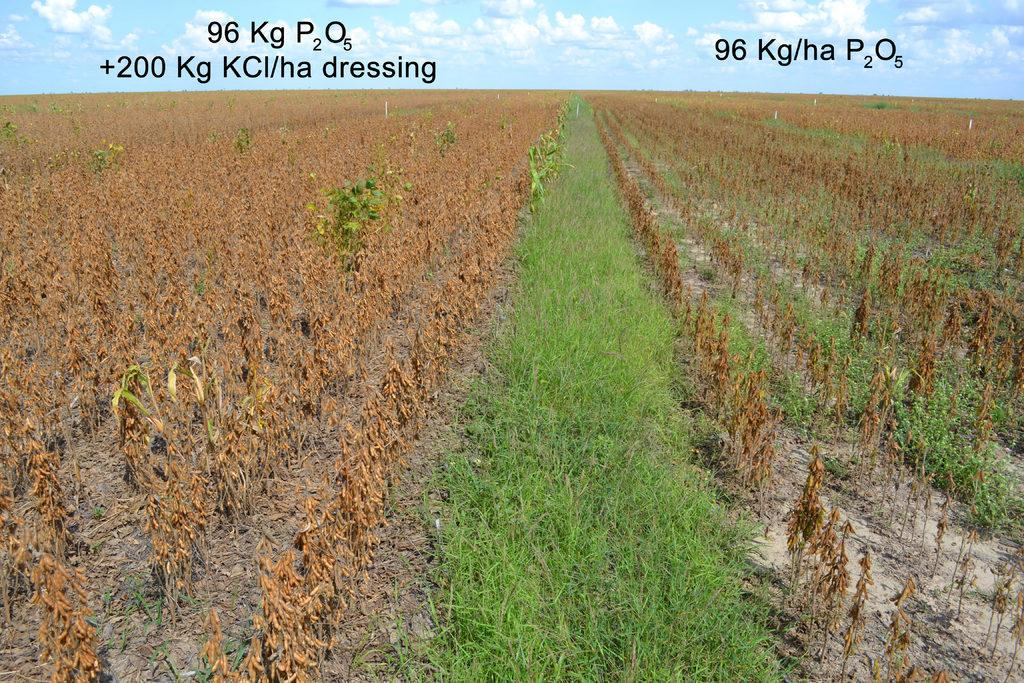What type of vegetation is on the left side of the image? There are dried plants on the left side of the image. What type of vegetation is in the middle of the image? There is green grass in the middle of the image. What is visible at the top of the image? The sky is visible at the top of the image. How would you describe the weather based on the appearance of the sky? The sky appears to be sunny, suggesting good weather. Can you describe the cloud that caused the earthquake in the image? There is no cloud or earthquake present in the image. How many times did the plant get bitten by the invisible creature in the image? There is no creature or biting action present in the image. 